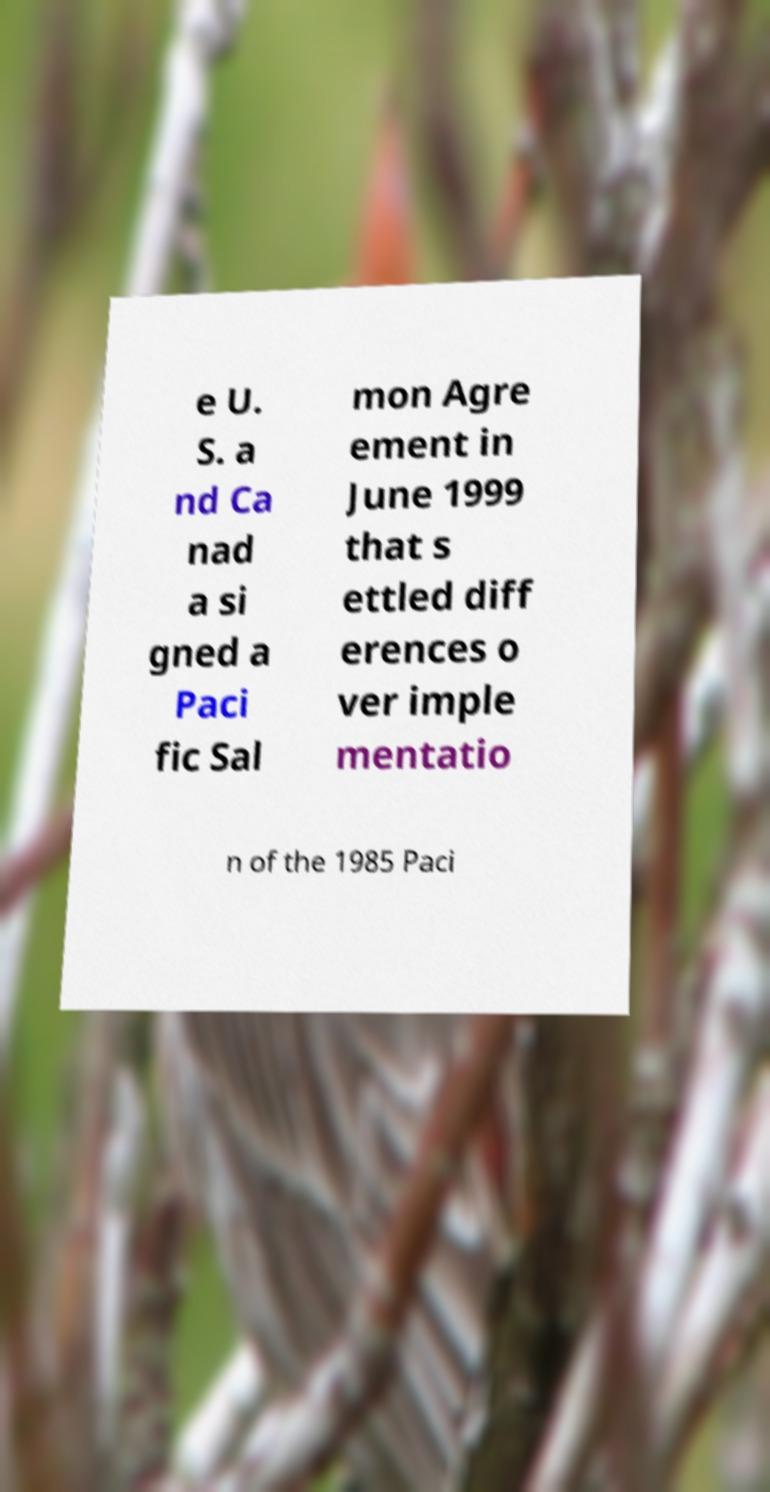For documentation purposes, I need the text within this image transcribed. Could you provide that? e U. S. a nd Ca nad a si gned a Paci fic Sal mon Agre ement in June 1999 that s ettled diff erences o ver imple mentatio n of the 1985 Paci 